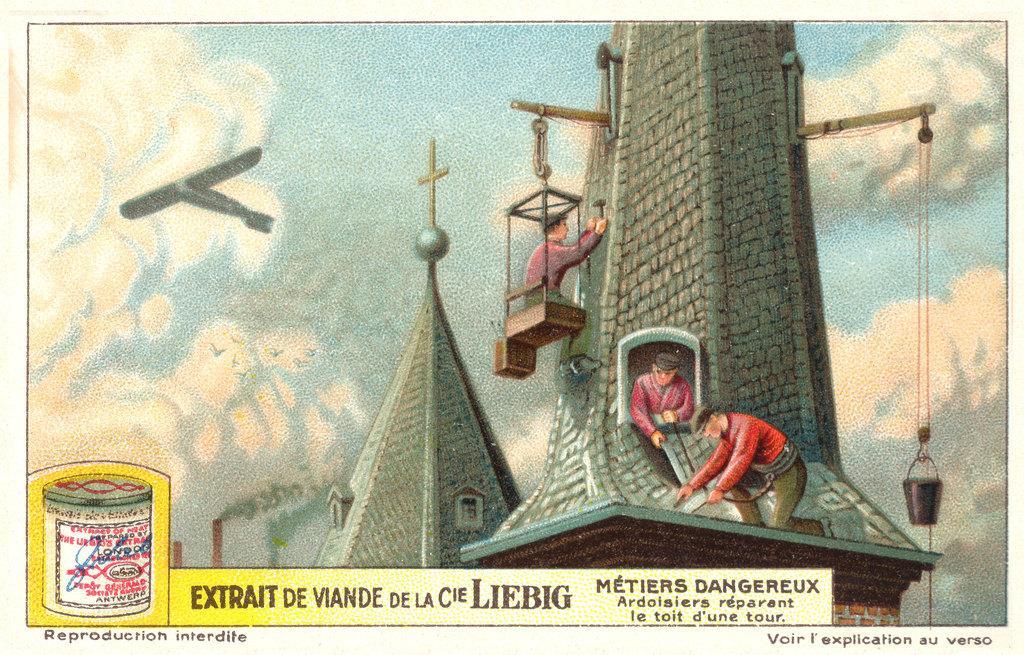Describe this image in one or two sentences. In this image we can see we can see a church. We can see few people working on the church. There is an aircraft at the left side of the image. We can see the clouds in the sky. There is some text at the bottom of the image. There is a rope and a bucket at the right side of the image. There is a box at the left side of the image. We can see the chimneys and smoke in the image. 